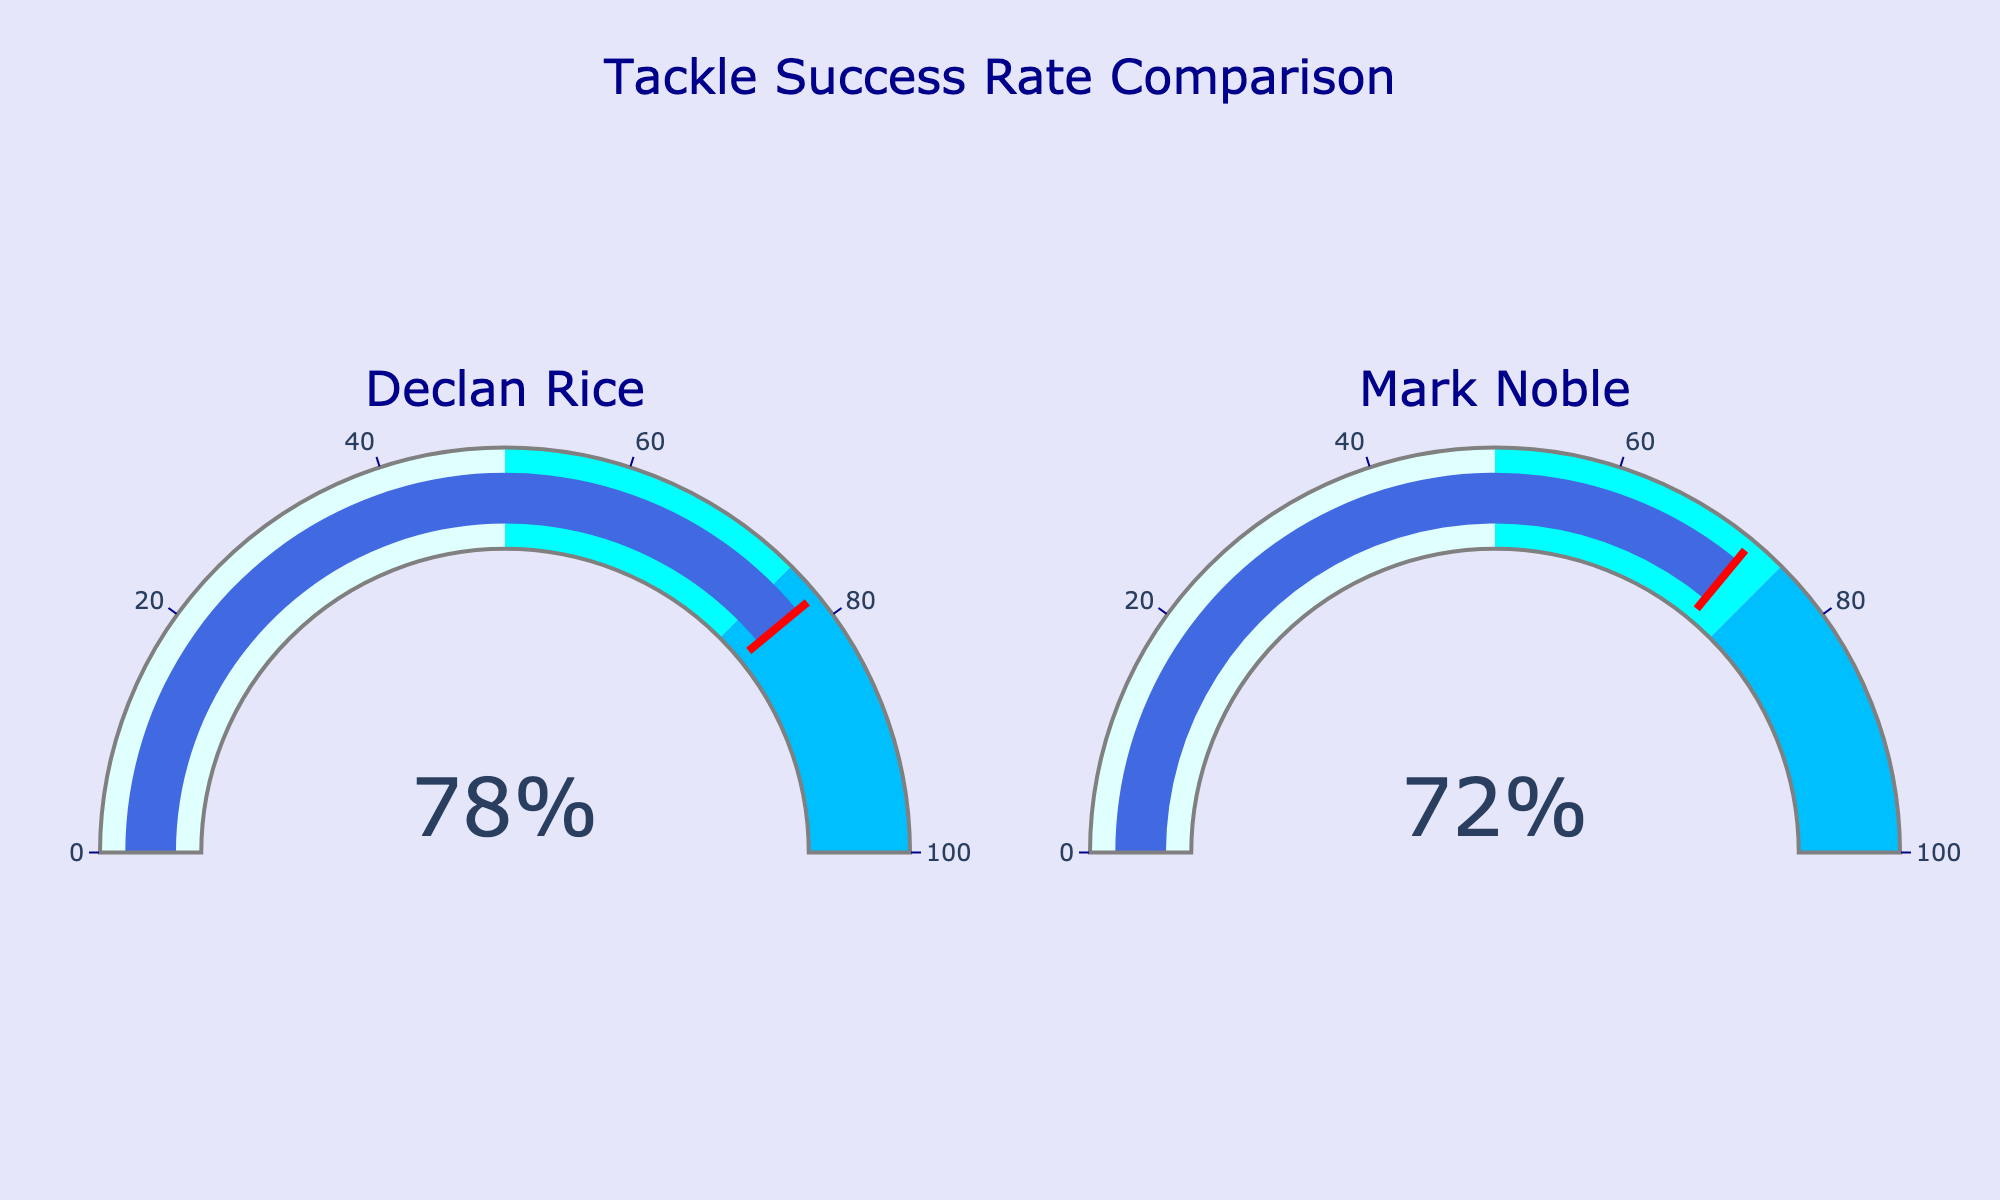What is the tackle success rate of Declan Rice according to the gauge chart? Declan Rice's tackle success rate is displayed as the large number on the gauge associated with his name.
Answer: 78% What is the tackle success rate of Mark Noble according to the gauge chart? Mark Noble's tackle success rate is displayed as the large number on the gauge associated with his name.
Answer: 72% Which player has a higher tackle success rate? By comparing the two numbers displayed on each gauge, we can see that Declan Rice's rate (78%) is higher than Mark Noble's (72%).
Answer: Declan Rice What is the difference in tackle success rate between Declan Rice and Mark Noble? Subtract Mark Noble's rate (72%) from Declan Rice's rate (78%) to get the difference. 78 - 72 = 6
Answer: 6% Considering the color thresholds in the gauge, how many colors does Declan Rice's tackle success rate span? The different colored sections indicate tackle success thresholds. Declan Rice's rate (78%) spans from the "light cyan" to "deepskyblue" section.
Answer: 3 colors What is the lower tackle success rate threshold marked by a noticeably different color? The gauge chart uses different colors to mark various thresholds. The light cyan region marks rates from 0% to 50%.
Answer: 50% From the gauges, what is the highest tackle success percentage displayed? By looking at the maximum value shown across both gauges, we see the highest percentage is 78%.
Answer: 78% Which player's tackle success rate is above 75%? Analyzing the numbers presented: Declan Rice (78%) is the only one above 75%.
Answer: Declan Rice If the average tackle success rate of both players were to be calculated, what would it be? Add both tackle success rates and divide by the number of players: (78% + 72%) / 2 = 75%.
Answer: 75% Is Mark Noble's tackle success rate above 50%? By examining Mark Noble's gauge, the indicated success rate of 72% is above 50%.
Answer: Yes 